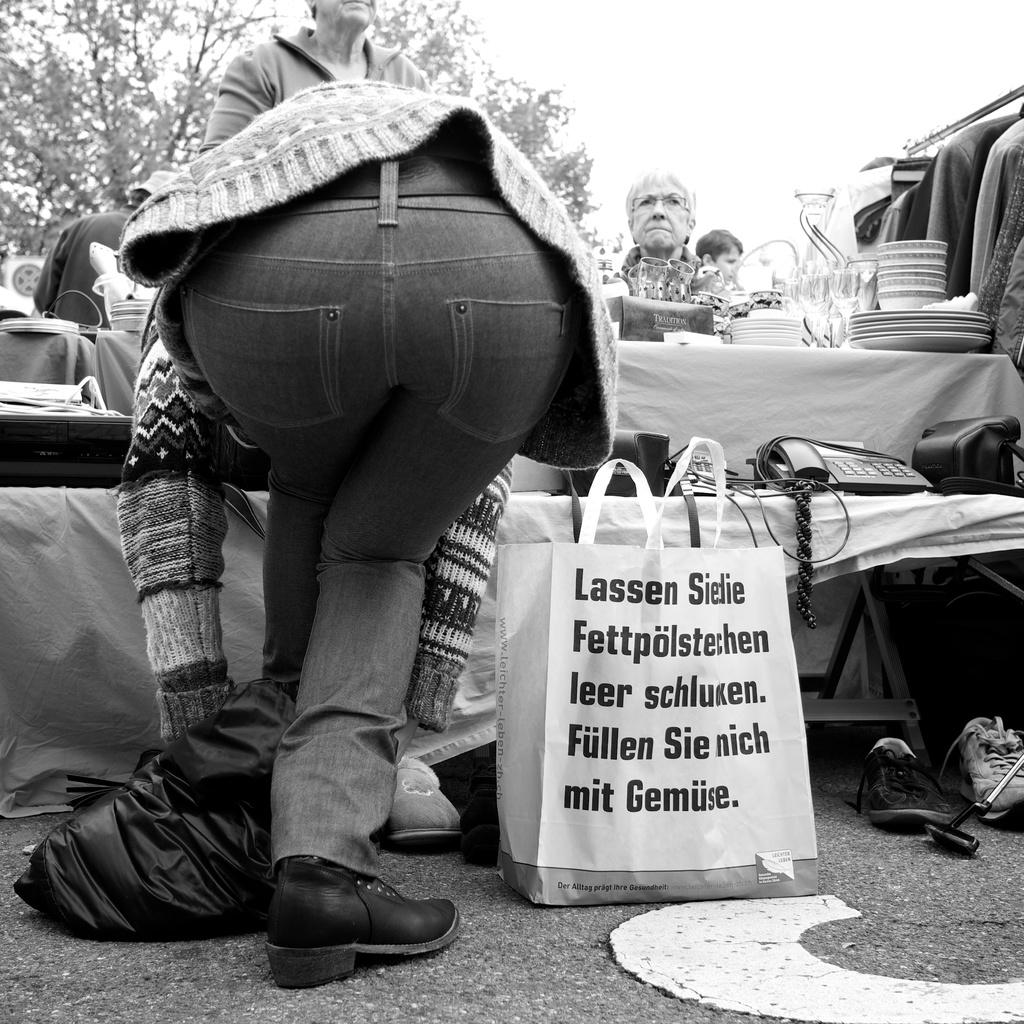Provide a one-sentence caption for the provided image. Person standing in front of a bag which starts with the word "Lassen". 